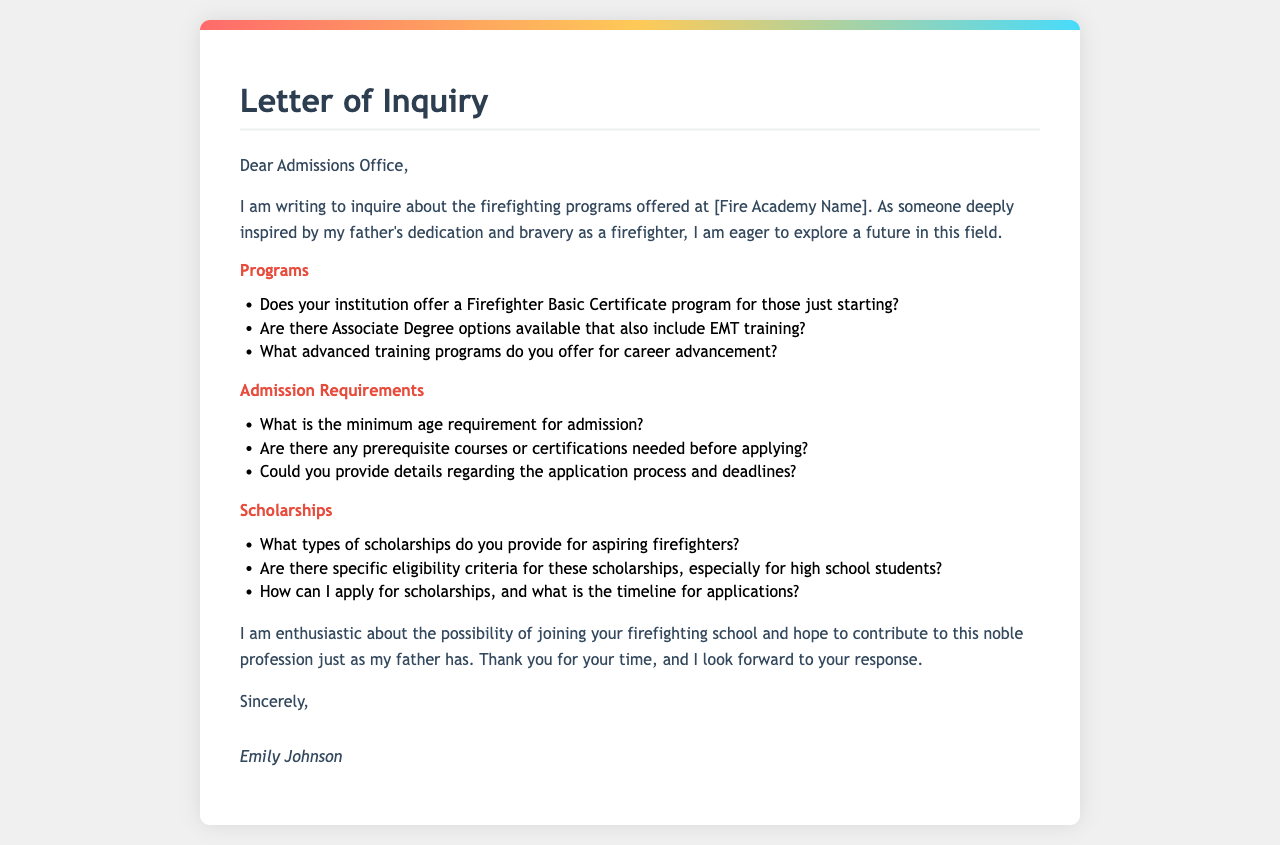What is the document type? The document is a letter addressed to the Admissions Office of a firefighting school.
Answer: Letter Who is the author of the letter? The letter is signed by Emily Johnson.
Answer: Emily Johnson What programs are inquired about? The letter asks about the Firefighter Basic Certificate program and Associate Degree options including EMT training.
Answer: Firefighter Basic Certificate program; Associate Degree options What is requested regarding admission requirements? The letter seeks information about the minimum age requirement for admission.
Answer: Minimum age requirement What types of scholarships are mentioned? The author asks about the types of scholarships provided for aspiring firefighters.
Answer: Scholarships for aspiring firefighters What is the reason for writing the letter? The author is inspired by her father's dedication and bravery as a firefighter.
Answer: Inspired by father's dedication and bravery What is the tone of the letter? The letter expresses enthusiasm about the possibility of joining the firefighting school.
Answer: Enthusiastic What information does the letter request regarding application deadlines? The author asks for details about the application process and deadlines.
Answer: Application process and deadlines How does the author conclude the letter? The author thanks the recipient for their time and expresses anticipation for a response.
Answer: Thanks and anticipation for a response 